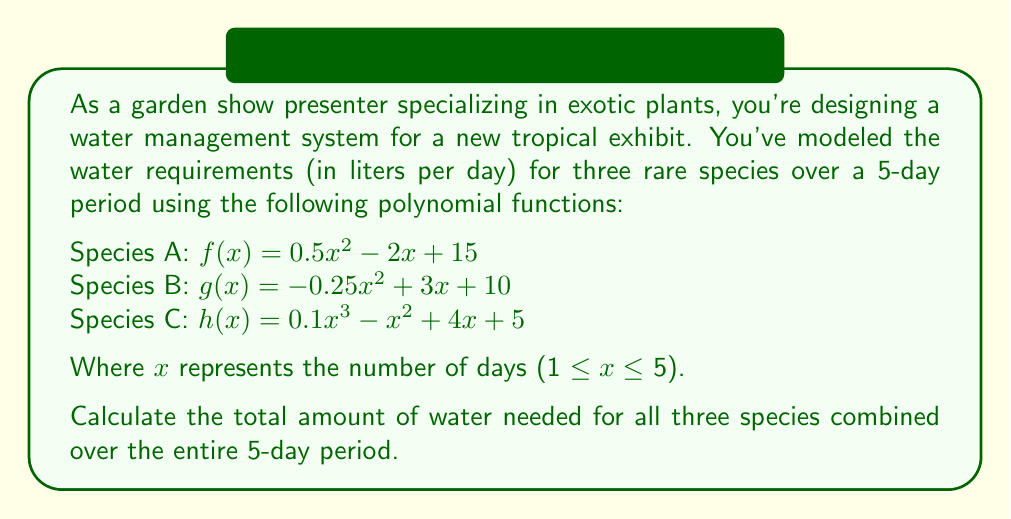Could you help me with this problem? To solve this problem, we need to follow these steps:

1. Calculate the water requirements for each species for each day (x = 1 to 5).
2. Sum up the daily requirements for all three species.
3. Add up the total requirements for all 5 days.

Let's start with the calculations:

Day 1 (x = 1):
Species A: $f(1) = 0.5(1)^2 - 2(1) + 15 = 13.5$
Species B: $g(1) = -0.25(1)^2 + 3(1) + 10 = 12.75$
Species C: $h(1) = 0.1(1)^3 - (1)^2 + 4(1) + 5 = 8.1$
Total for Day 1: $13.5 + 12.75 + 8.1 = 34.35$

Day 2 (x = 2):
Species A: $f(2) = 0.5(2)^2 - 2(2) + 15 = 13$
Species B: $g(2) = -0.25(2)^2 + 3(2) + 10 = 14$
Species C: $h(2) = 0.1(2)^3 - (2)^2 + 4(2) + 5 = 9.8$
Total for Day 2: $13 + 14 + 9.8 = 36.8$

Day 3 (x = 3):
Species A: $f(3) = 0.5(3)^2 - 2(3) + 15 = 13.5$
Species B: $g(3) = -0.25(3)^2 + 3(3) + 10 = 13.75$
Species C: $h(3) = 0.1(3)^3 - (3)^2 + 4(3) + 5 = 11.7$
Total for Day 3: $13.5 + 13.75 + 11.7 = 38.95$

Day 4 (x = 4):
Species A: $f(4) = 0.5(4)^2 - 2(4) + 15 = 15$
Species B: $g(4) = -0.25(4)^2 + 3(4) + 10 = 12$
Species C: $h(4) = 0.1(4)^3 - (4)^2 + 4(4) + 5 = 13.6$
Total for Day 4: $15 + 12 + 13.6 = 40.6$

Day 5 (x = 5):
Species A: $f(5) = 0.5(5)^2 - 2(5) + 15 = 17.5$
Species B: $g(5) = -0.25(5)^2 + 3(5) + 10 = 8.75$
Species C: $h(5) = 0.1(5)^3 - (5)^2 + 4(5) + 5 = 15.5$
Total for Day 5: $17.5 + 8.75 + 15.5 = 41.75$

Now, we sum up the daily totals:
$34.35 + 36.8 + 38.95 + 40.6 + 41.75 = 192.45$

Therefore, the total amount of water needed for all three species combined over the 5-day period is 192.45 liters.
Answer: 192.45 liters 